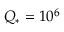<formula> <loc_0><loc_0><loc_500><loc_500>Q _ { * } = 1 0 ^ { 6 }</formula> 